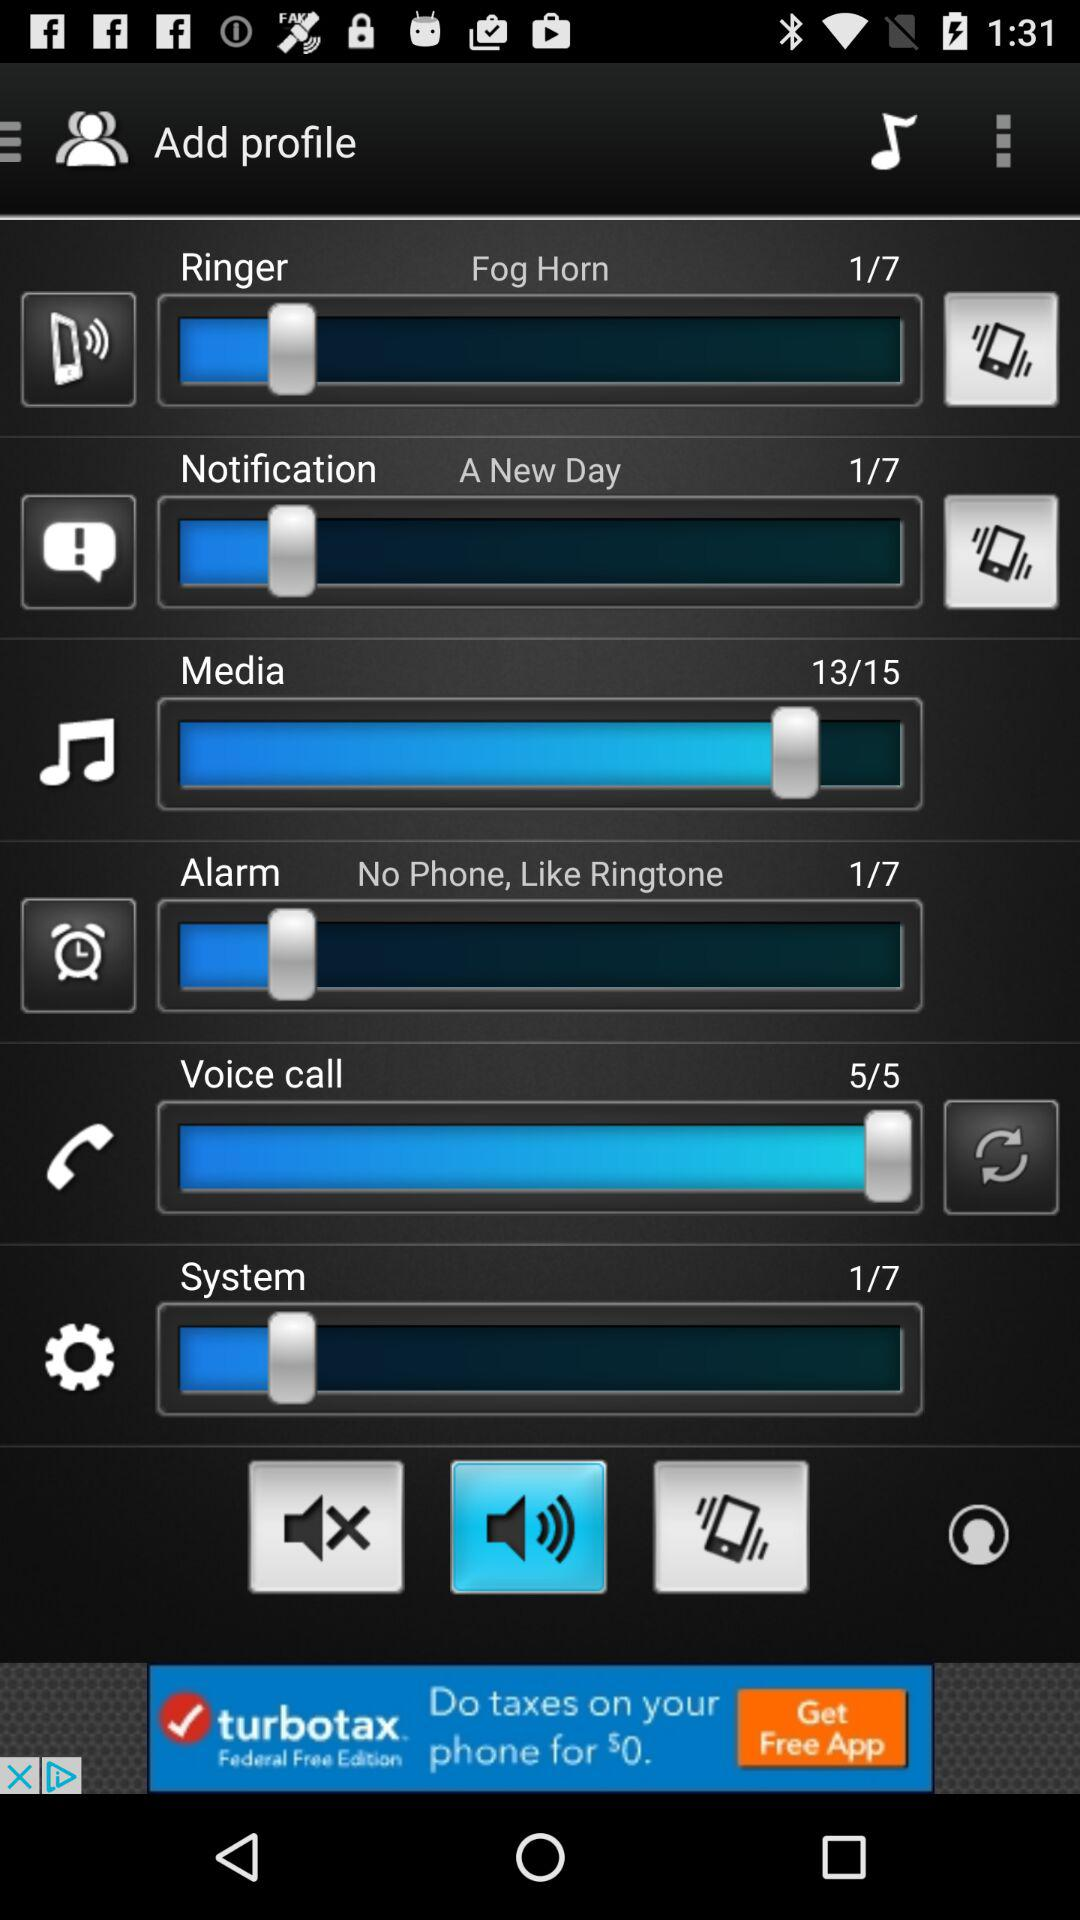What is the media volume level? The media volume level is 13. 